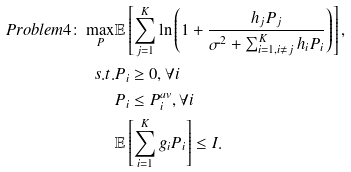<formula> <loc_0><loc_0><loc_500><loc_500>P r o b l e m 4 \colon \max _ { P } & \mathbb { E } \left [ \sum _ { j = 1 } ^ { K } \ln \left ( 1 + \frac { h _ { j } P _ { j } } { \sigma ^ { 2 } + \sum _ { i = 1 , i \neq j } ^ { K } h _ { i } P _ { i } } \right ) \right ] , \\ s . t . & P _ { i } \geq 0 , \forall i \\ & P _ { i } \leq P _ { i } ^ { a v } , \forall i \\ & \mathbb { E } \left [ \sum _ { i = 1 } ^ { K } g _ { i } P _ { i } \right ] \leq I .</formula> 